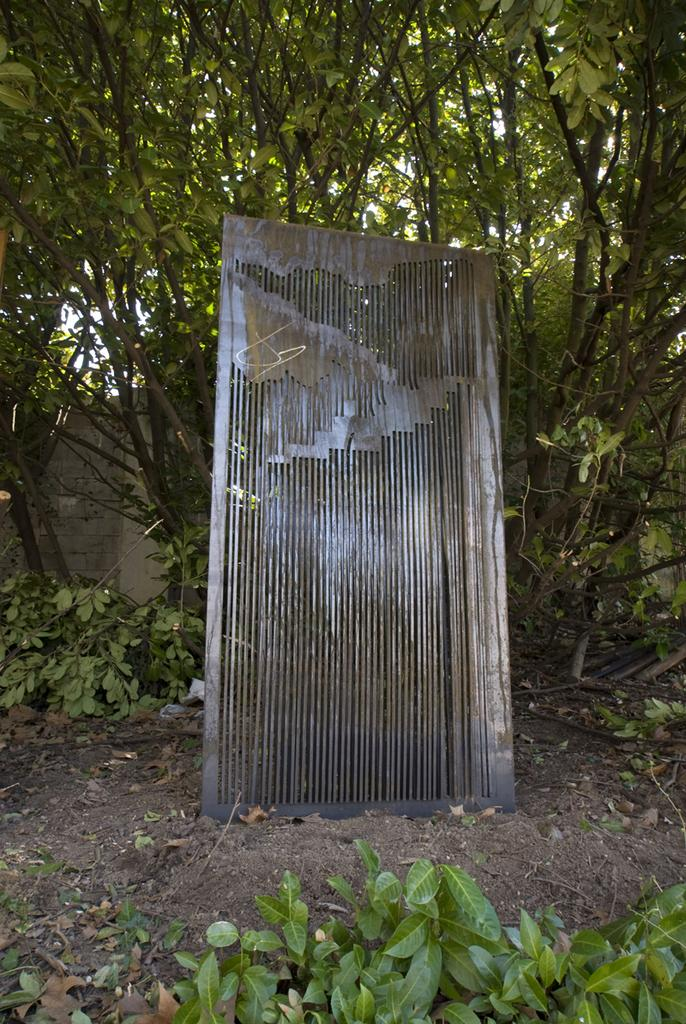What type of vegetation is visible in the front of the image? There are leaves in the front of the image. What can be found in the center of the image? There is a metal object in the center of the image. What type of natural scenery is visible in the background of the image? There are trees in the background of the image. How does the metal object look in the image? The metal object's appearance cannot be described in terms of "looking" as it is an inanimate object. Can you tell me how many noses are visible in the image? There are no noses present in the image. 